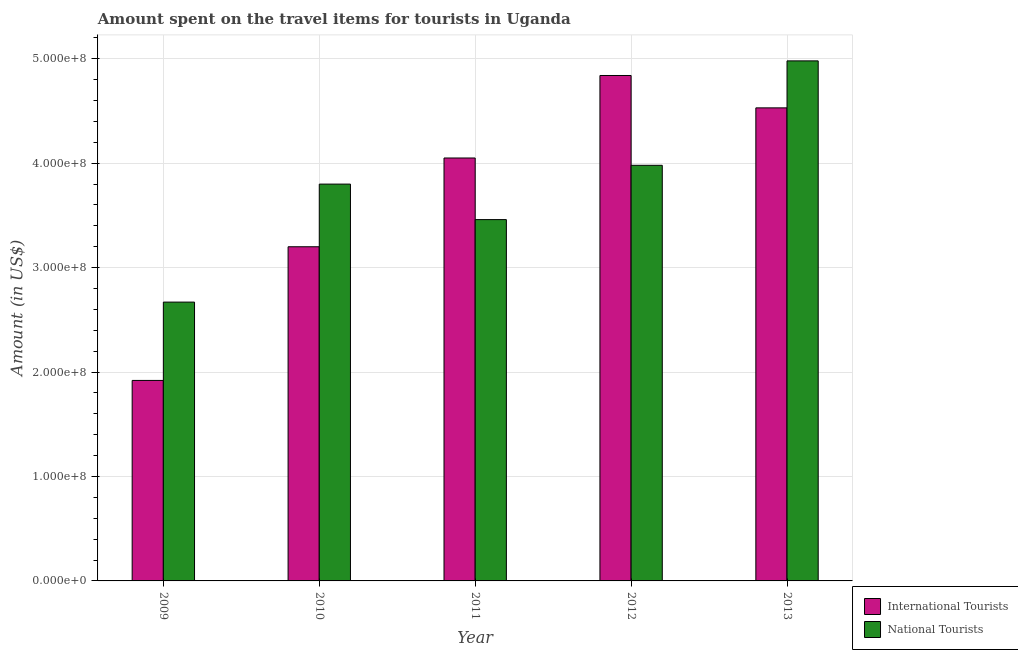Are the number of bars on each tick of the X-axis equal?
Your answer should be compact. Yes. How many bars are there on the 3rd tick from the left?
Your answer should be very brief. 2. What is the label of the 4th group of bars from the left?
Ensure brevity in your answer.  2012. What is the amount spent on travel items of national tourists in 2009?
Your answer should be very brief. 2.67e+08. Across all years, what is the maximum amount spent on travel items of international tourists?
Your answer should be very brief. 4.84e+08. Across all years, what is the minimum amount spent on travel items of international tourists?
Offer a very short reply. 1.92e+08. In which year was the amount spent on travel items of international tourists minimum?
Make the answer very short. 2009. What is the total amount spent on travel items of national tourists in the graph?
Make the answer very short. 1.89e+09. What is the difference between the amount spent on travel items of international tourists in 2009 and that in 2010?
Make the answer very short. -1.28e+08. What is the difference between the amount spent on travel items of national tourists in 2010 and the amount spent on travel items of international tourists in 2009?
Provide a succinct answer. 1.13e+08. What is the average amount spent on travel items of national tourists per year?
Your answer should be compact. 3.78e+08. In the year 2012, what is the difference between the amount spent on travel items of international tourists and amount spent on travel items of national tourists?
Offer a very short reply. 0. In how many years, is the amount spent on travel items of national tourists greater than 380000000 US$?
Provide a succinct answer. 2. What is the ratio of the amount spent on travel items of international tourists in 2009 to that in 2013?
Make the answer very short. 0.42. Is the difference between the amount spent on travel items of national tourists in 2009 and 2010 greater than the difference between the amount spent on travel items of international tourists in 2009 and 2010?
Provide a short and direct response. No. What is the difference between the highest and the second highest amount spent on travel items of national tourists?
Provide a short and direct response. 1.00e+08. What is the difference between the highest and the lowest amount spent on travel items of national tourists?
Provide a short and direct response. 2.31e+08. Is the sum of the amount spent on travel items of international tourists in 2010 and 2012 greater than the maximum amount spent on travel items of national tourists across all years?
Give a very brief answer. Yes. What does the 2nd bar from the left in 2010 represents?
Your response must be concise. National Tourists. What does the 1st bar from the right in 2012 represents?
Your answer should be compact. National Tourists. How many bars are there?
Your answer should be compact. 10. How many years are there in the graph?
Offer a very short reply. 5. Are the values on the major ticks of Y-axis written in scientific E-notation?
Ensure brevity in your answer.  Yes. Does the graph contain any zero values?
Offer a very short reply. No. Where does the legend appear in the graph?
Your answer should be very brief. Bottom right. How many legend labels are there?
Keep it short and to the point. 2. How are the legend labels stacked?
Offer a terse response. Vertical. What is the title of the graph?
Your answer should be compact. Amount spent on the travel items for tourists in Uganda. Does "DAC donors" appear as one of the legend labels in the graph?
Provide a short and direct response. No. What is the Amount (in US$) in International Tourists in 2009?
Give a very brief answer. 1.92e+08. What is the Amount (in US$) in National Tourists in 2009?
Ensure brevity in your answer.  2.67e+08. What is the Amount (in US$) in International Tourists in 2010?
Provide a short and direct response. 3.20e+08. What is the Amount (in US$) of National Tourists in 2010?
Your response must be concise. 3.80e+08. What is the Amount (in US$) of International Tourists in 2011?
Your answer should be compact. 4.05e+08. What is the Amount (in US$) of National Tourists in 2011?
Provide a succinct answer. 3.46e+08. What is the Amount (in US$) of International Tourists in 2012?
Your response must be concise. 4.84e+08. What is the Amount (in US$) in National Tourists in 2012?
Keep it short and to the point. 3.98e+08. What is the Amount (in US$) of International Tourists in 2013?
Give a very brief answer. 4.53e+08. What is the Amount (in US$) in National Tourists in 2013?
Give a very brief answer. 4.98e+08. Across all years, what is the maximum Amount (in US$) of International Tourists?
Provide a short and direct response. 4.84e+08. Across all years, what is the maximum Amount (in US$) in National Tourists?
Your answer should be very brief. 4.98e+08. Across all years, what is the minimum Amount (in US$) in International Tourists?
Your answer should be very brief. 1.92e+08. Across all years, what is the minimum Amount (in US$) in National Tourists?
Your response must be concise. 2.67e+08. What is the total Amount (in US$) in International Tourists in the graph?
Give a very brief answer. 1.85e+09. What is the total Amount (in US$) in National Tourists in the graph?
Your answer should be very brief. 1.89e+09. What is the difference between the Amount (in US$) in International Tourists in 2009 and that in 2010?
Keep it short and to the point. -1.28e+08. What is the difference between the Amount (in US$) in National Tourists in 2009 and that in 2010?
Provide a succinct answer. -1.13e+08. What is the difference between the Amount (in US$) in International Tourists in 2009 and that in 2011?
Keep it short and to the point. -2.13e+08. What is the difference between the Amount (in US$) of National Tourists in 2009 and that in 2011?
Your answer should be very brief. -7.90e+07. What is the difference between the Amount (in US$) in International Tourists in 2009 and that in 2012?
Provide a short and direct response. -2.92e+08. What is the difference between the Amount (in US$) in National Tourists in 2009 and that in 2012?
Ensure brevity in your answer.  -1.31e+08. What is the difference between the Amount (in US$) in International Tourists in 2009 and that in 2013?
Provide a succinct answer. -2.61e+08. What is the difference between the Amount (in US$) of National Tourists in 2009 and that in 2013?
Make the answer very short. -2.31e+08. What is the difference between the Amount (in US$) of International Tourists in 2010 and that in 2011?
Give a very brief answer. -8.50e+07. What is the difference between the Amount (in US$) in National Tourists in 2010 and that in 2011?
Give a very brief answer. 3.40e+07. What is the difference between the Amount (in US$) in International Tourists in 2010 and that in 2012?
Your answer should be compact. -1.64e+08. What is the difference between the Amount (in US$) of National Tourists in 2010 and that in 2012?
Provide a succinct answer. -1.80e+07. What is the difference between the Amount (in US$) in International Tourists in 2010 and that in 2013?
Offer a terse response. -1.33e+08. What is the difference between the Amount (in US$) of National Tourists in 2010 and that in 2013?
Provide a succinct answer. -1.18e+08. What is the difference between the Amount (in US$) of International Tourists in 2011 and that in 2012?
Keep it short and to the point. -7.90e+07. What is the difference between the Amount (in US$) of National Tourists in 2011 and that in 2012?
Your answer should be compact. -5.20e+07. What is the difference between the Amount (in US$) in International Tourists in 2011 and that in 2013?
Ensure brevity in your answer.  -4.80e+07. What is the difference between the Amount (in US$) of National Tourists in 2011 and that in 2013?
Offer a terse response. -1.52e+08. What is the difference between the Amount (in US$) in International Tourists in 2012 and that in 2013?
Provide a succinct answer. 3.10e+07. What is the difference between the Amount (in US$) in National Tourists in 2012 and that in 2013?
Provide a short and direct response. -1.00e+08. What is the difference between the Amount (in US$) in International Tourists in 2009 and the Amount (in US$) in National Tourists in 2010?
Your response must be concise. -1.88e+08. What is the difference between the Amount (in US$) of International Tourists in 2009 and the Amount (in US$) of National Tourists in 2011?
Give a very brief answer. -1.54e+08. What is the difference between the Amount (in US$) of International Tourists in 2009 and the Amount (in US$) of National Tourists in 2012?
Your response must be concise. -2.06e+08. What is the difference between the Amount (in US$) in International Tourists in 2009 and the Amount (in US$) in National Tourists in 2013?
Ensure brevity in your answer.  -3.06e+08. What is the difference between the Amount (in US$) in International Tourists in 2010 and the Amount (in US$) in National Tourists in 2011?
Your response must be concise. -2.60e+07. What is the difference between the Amount (in US$) in International Tourists in 2010 and the Amount (in US$) in National Tourists in 2012?
Give a very brief answer. -7.80e+07. What is the difference between the Amount (in US$) in International Tourists in 2010 and the Amount (in US$) in National Tourists in 2013?
Ensure brevity in your answer.  -1.78e+08. What is the difference between the Amount (in US$) of International Tourists in 2011 and the Amount (in US$) of National Tourists in 2013?
Ensure brevity in your answer.  -9.30e+07. What is the difference between the Amount (in US$) of International Tourists in 2012 and the Amount (in US$) of National Tourists in 2013?
Offer a very short reply. -1.40e+07. What is the average Amount (in US$) in International Tourists per year?
Offer a terse response. 3.71e+08. What is the average Amount (in US$) of National Tourists per year?
Your answer should be compact. 3.78e+08. In the year 2009, what is the difference between the Amount (in US$) of International Tourists and Amount (in US$) of National Tourists?
Your response must be concise. -7.50e+07. In the year 2010, what is the difference between the Amount (in US$) of International Tourists and Amount (in US$) of National Tourists?
Give a very brief answer. -6.00e+07. In the year 2011, what is the difference between the Amount (in US$) in International Tourists and Amount (in US$) in National Tourists?
Your answer should be very brief. 5.90e+07. In the year 2012, what is the difference between the Amount (in US$) in International Tourists and Amount (in US$) in National Tourists?
Your answer should be very brief. 8.60e+07. In the year 2013, what is the difference between the Amount (in US$) in International Tourists and Amount (in US$) in National Tourists?
Provide a short and direct response. -4.50e+07. What is the ratio of the Amount (in US$) of National Tourists in 2009 to that in 2010?
Ensure brevity in your answer.  0.7. What is the ratio of the Amount (in US$) in International Tourists in 2009 to that in 2011?
Your answer should be very brief. 0.47. What is the ratio of the Amount (in US$) in National Tourists in 2009 to that in 2011?
Ensure brevity in your answer.  0.77. What is the ratio of the Amount (in US$) of International Tourists in 2009 to that in 2012?
Your response must be concise. 0.4. What is the ratio of the Amount (in US$) in National Tourists in 2009 to that in 2012?
Give a very brief answer. 0.67. What is the ratio of the Amount (in US$) of International Tourists in 2009 to that in 2013?
Keep it short and to the point. 0.42. What is the ratio of the Amount (in US$) in National Tourists in 2009 to that in 2013?
Give a very brief answer. 0.54. What is the ratio of the Amount (in US$) of International Tourists in 2010 to that in 2011?
Your answer should be compact. 0.79. What is the ratio of the Amount (in US$) of National Tourists in 2010 to that in 2011?
Your answer should be very brief. 1.1. What is the ratio of the Amount (in US$) of International Tourists in 2010 to that in 2012?
Provide a succinct answer. 0.66. What is the ratio of the Amount (in US$) of National Tourists in 2010 to that in 2012?
Make the answer very short. 0.95. What is the ratio of the Amount (in US$) of International Tourists in 2010 to that in 2013?
Ensure brevity in your answer.  0.71. What is the ratio of the Amount (in US$) in National Tourists in 2010 to that in 2013?
Your response must be concise. 0.76. What is the ratio of the Amount (in US$) in International Tourists in 2011 to that in 2012?
Provide a succinct answer. 0.84. What is the ratio of the Amount (in US$) in National Tourists in 2011 to that in 2012?
Offer a very short reply. 0.87. What is the ratio of the Amount (in US$) in International Tourists in 2011 to that in 2013?
Provide a short and direct response. 0.89. What is the ratio of the Amount (in US$) in National Tourists in 2011 to that in 2013?
Provide a succinct answer. 0.69. What is the ratio of the Amount (in US$) of International Tourists in 2012 to that in 2013?
Give a very brief answer. 1.07. What is the ratio of the Amount (in US$) in National Tourists in 2012 to that in 2013?
Your response must be concise. 0.8. What is the difference between the highest and the second highest Amount (in US$) in International Tourists?
Your answer should be compact. 3.10e+07. What is the difference between the highest and the lowest Amount (in US$) in International Tourists?
Provide a succinct answer. 2.92e+08. What is the difference between the highest and the lowest Amount (in US$) in National Tourists?
Make the answer very short. 2.31e+08. 